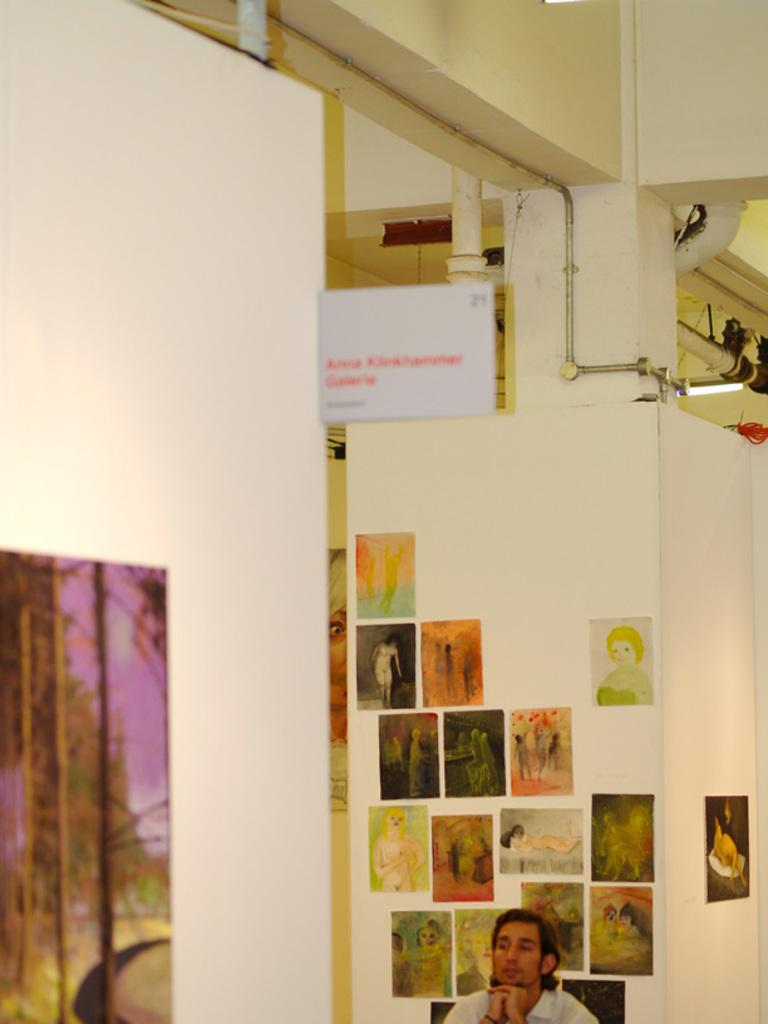What is the person in the image doing? The person is sitting in a chair in the image. What can be seen on the walls around the person? There are photo frames on the walls around the person. What is visible at the top of the image? There are pipes and lamps at the top of the image. How many cracks can be seen in the person's chair in the image? There is no mention of cracks in the chair in the image, so it cannot be determined from the provided facts. 